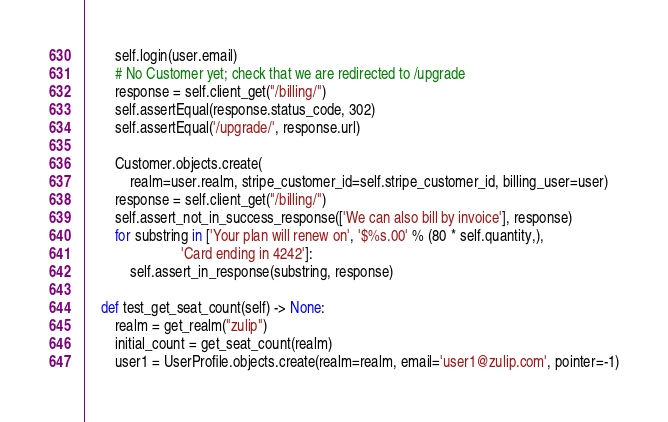Convert code to text. <code><loc_0><loc_0><loc_500><loc_500><_Python_>        self.login(user.email)
        # No Customer yet; check that we are redirected to /upgrade
        response = self.client_get("/billing/")
        self.assertEqual(response.status_code, 302)
        self.assertEqual('/upgrade/', response.url)

        Customer.objects.create(
            realm=user.realm, stripe_customer_id=self.stripe_customer_id, billing_user=user)
        response = self.client_get("/billing/")
        self.assert_not_in_success_response(['We can also bill by invoice'], response)
        for substring in ['Your plan will renew on', '$%s.00' % (80 * self.quantity,),
                          'Card ending in 4242']:
            self.assert_in_response(substring, response)

    def test_get_seat_count(self) -> None:
        realm = get_realm("zulip")
        initial_count = get_seat_count(realm)
        user1 = UserProfile.objects.create(realm=realm, email='user1@zulip.com', pointer=-1)</code> 